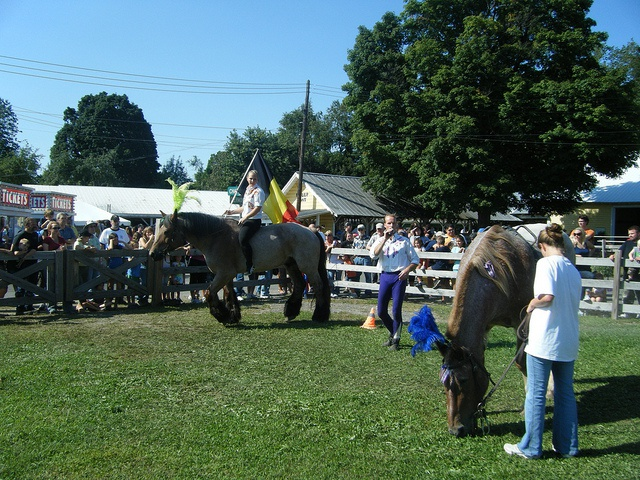Describe the objects in this image and their specific colors. I can see horse in lightblue, black, gray, darkgreen, and darkgray tones, people in lightblue, white, gray, black, and navy tones, horse in lightblue, black, darkblue, gray, and blue tones, people in lightblue, black, gray, lightgray, and navy tones, and people in lightblue, black, white, gray, and navy tones in this image. 